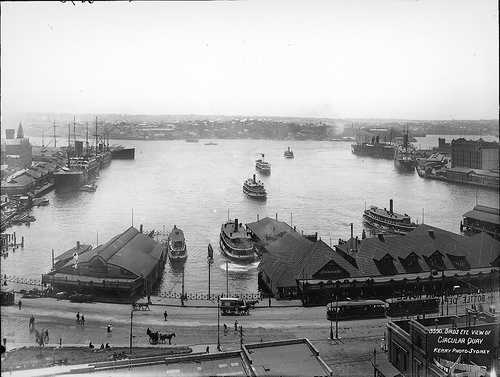Describe the objects in this image and their specific colors. I can see boat in black, gray, and lightgray tones, boat in black, gray, darkgray, and lightgray tones, train in black, gray, and lightgray tones, boat in black, gray, darkgray, and lightgray tones, and boat in black, gray, darkgray, and lightgray tones in this image. 